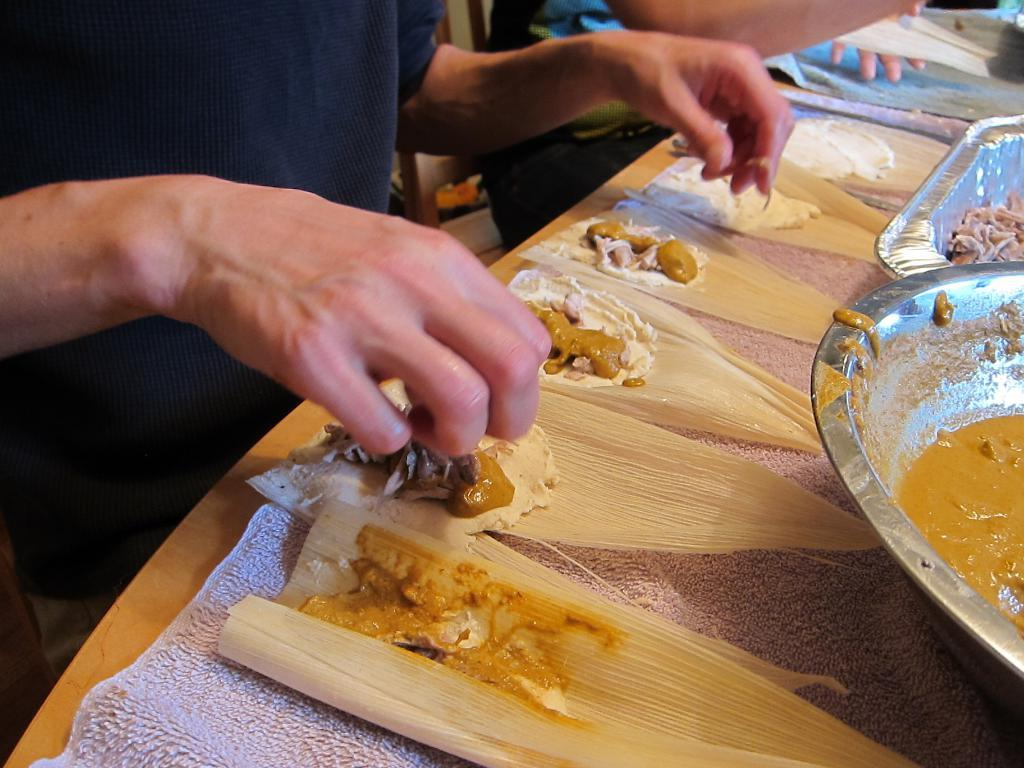What are the people in the image doing? The people in the image are seated on chairs. How is the food being served in the image? The food is present on leaves on the table. What type of container is on the table? There is a bowl on the table. What other item is on the table? There is an aluminium tray on the table. How many dimes are placed on the leaves with the food in the image? There are no dimes present on the leaves with the food in the image. What type of fuel is being used to cook the food in the image? There is no indication of cooking or fuel in the image; it only shows people seated with food on leaves, a bowl, and an aluminium tray on the table. 